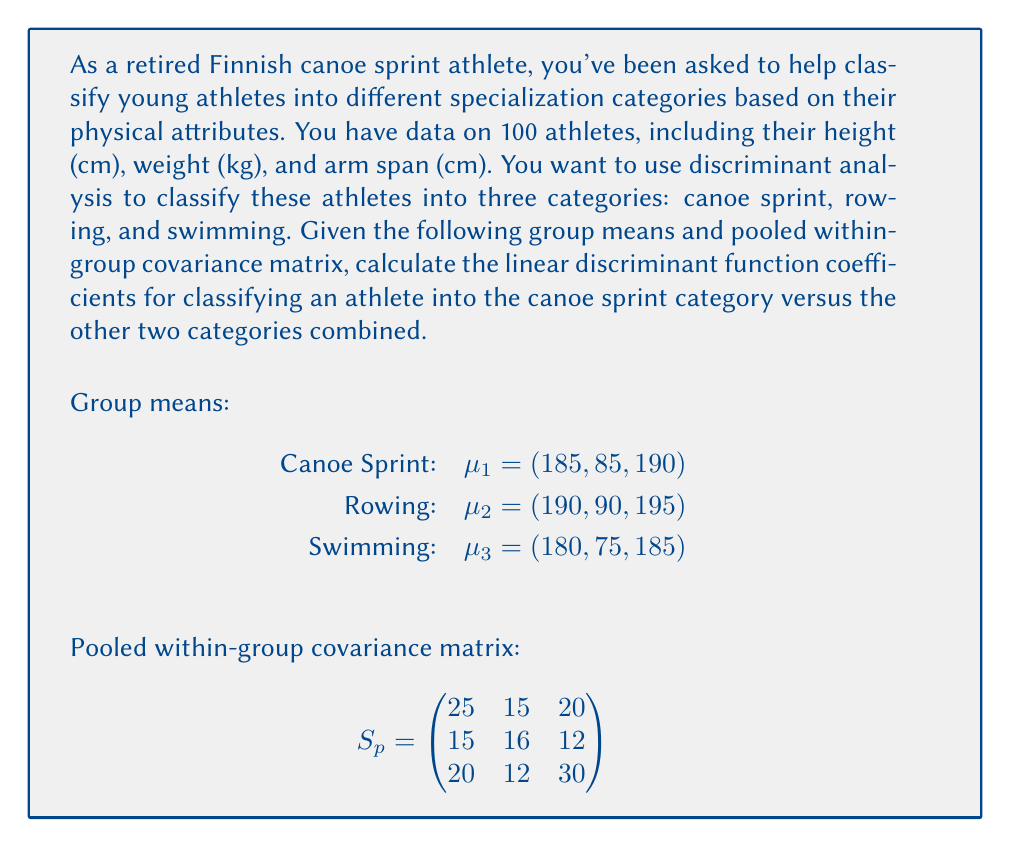Can you solve this math problem? To solve this problem, we'll follow these steps:

1) First, we need to calculate the overall mean of all groups:
   $$\bar{x} = \frac{1}{3}(\mu_1 + \mu_2 + \mu_3) = \frac{1}{3}((185, 85, 190) + (190, 90, 195) + (180, 75, 185))$$
   $$\bar{x} = (185, 83.33, 190)$$

2) Now, we calculate the difference between the canoe sprint group mean and the overall mean:
   $$\mu_1 - \bar{x} = (185, 85, 190) - (185, 83.33, 190) = (0, 1.67, 0)$$

3) The linear discriminant function coefficients are given by:
   $$a = S_p^{-1}(\mu_1 - \bar{x})$$

4) To find $S_p^{-1}$, we need to invert the pooled within-group covariance matrix:
   $$S_p^{-1} = \begin{pmatrix}
   0.0559 & -0.0474 & -0.0316 \\
   -0.0474 & 0.0899 & -0.0158 \\
   -0.0316 & -0.0158 & 0.0474
   \end{pmatrix}$$

5) Now we can calculate $a$:
   $$a = \begin{pmatrix}
   0.0559 & -0.0474 & -0.0316 \\
   -0.0474 & 0.0899 & -0.0158 \\
   -0.0316 & -0.0158 & 0.0474
   \end{pmatrix} \times \begin{pmatrix}
   0 \\
   1.67 \\
   0
   \end{pmatrix}$$

6) Performing the matrix multiplication:
   $$a = \begin{pmatrix}
   -0.0791 \\
   0.1501 \\
   -0.0264
   \end{pmatrix}$$

These are the linear discriminant function coefficients for classifying an athlete into the canoe sprint category versus the other two categories combined.
Answer: The linear discriminant function coefficients for classifying an athlete into the canoe sprint category are:

$$a = \begin{pmatrix}
-0.0791 \\
0.1501 \\
-0.0264
\end{pmatrix}$$ 